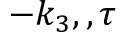<formula> <loc_0><loc_0><loc_500><loc_500>- k _ { 3 } , , \tau</formula> 